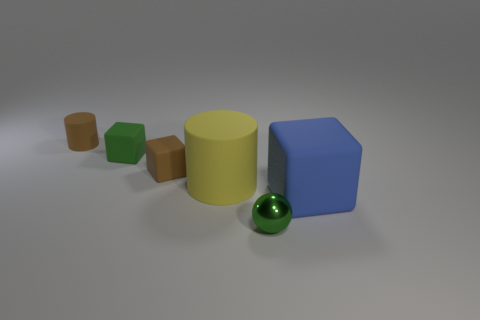What number of big blue objects have the same shape as the tiny green matte object?
Offer a terse response. 1. How many objects are tiny brown things that are in front of the tiny brown rubber cylinder or brown objects that are on the right side of the small green matte object?
Keep it short and to the point. 1. What number of gray things are either matte spheres or shiny objects?
Your answer should be very brief. 0. What is the material of the small object that is to the left of the small green sphere and to the right of the tiny green rubber object?
Make the answer very short. Rubber. Does the brown cylinder have the same material as the green block?
Your response must be concise. Yes. What number of blue blocks have the same size as the green metal ball?
Give a very brief answer. 0. Are there an equal number of tiny spheres that are behind the small matte cylinder and large blue rubber cubes?
Offer a terse response. No. How many things are both behind the metallic object and on the left side of the blue rubber block?
Offer a terse response. 4. Does the tiny green metallic object that is in front of the brown matte block have the same shape as the yellow object?
Give a very brief answer. No. There is a green cube that is the same size as the brown rubber cylinder; what material is it?
Make the answer very short. Rubber. 